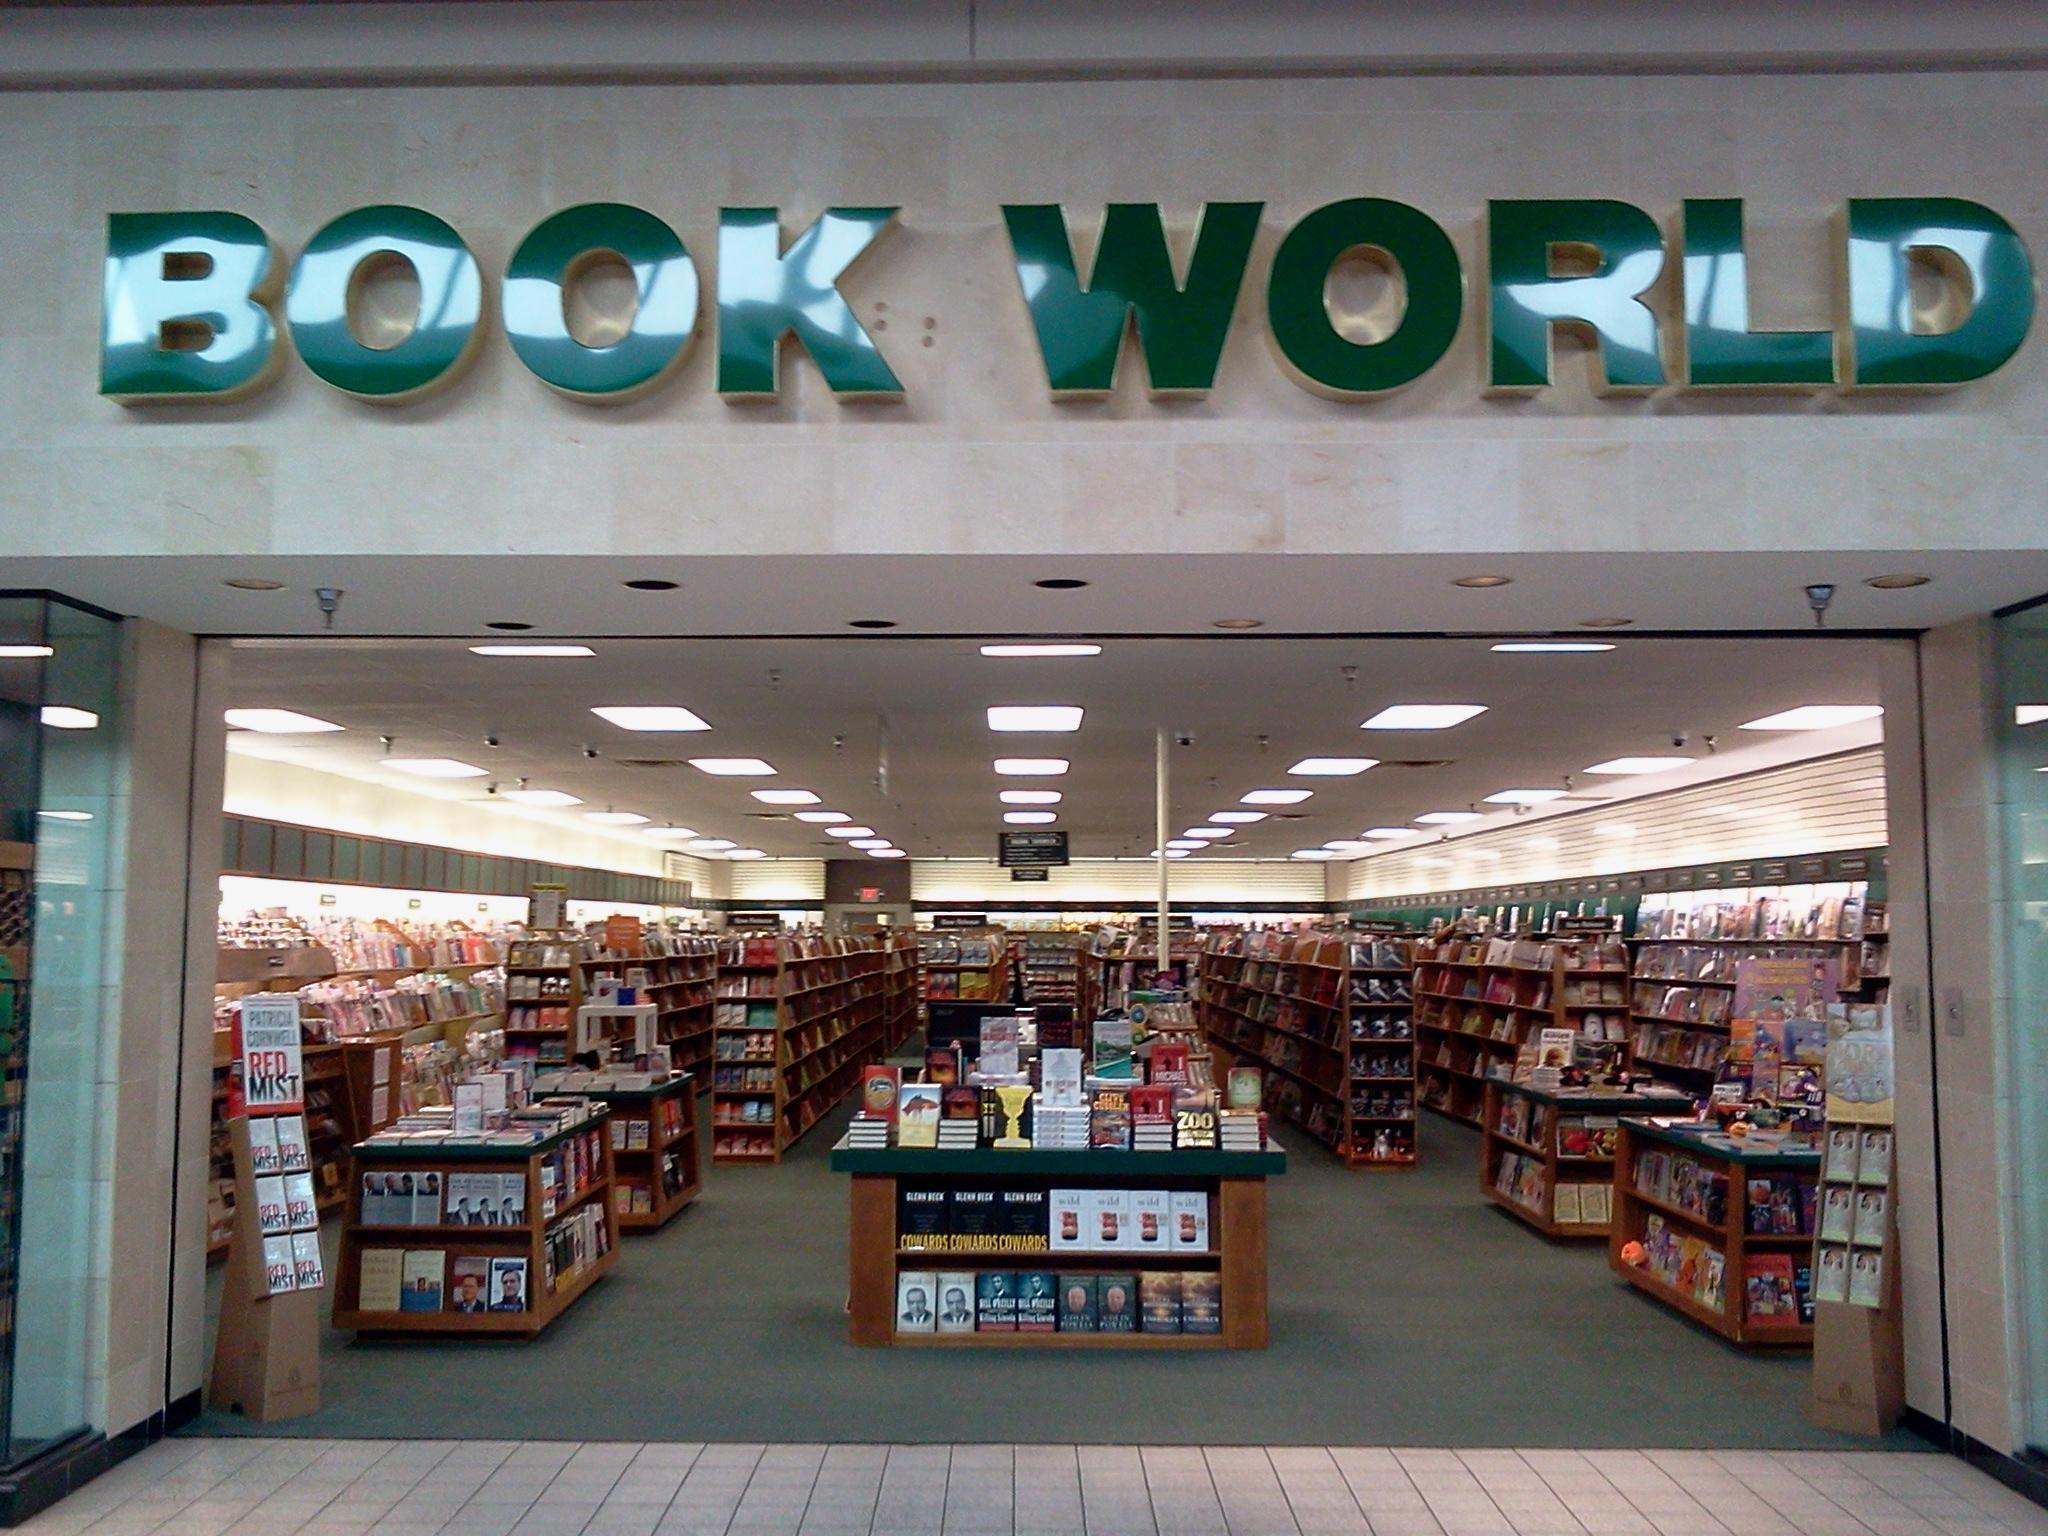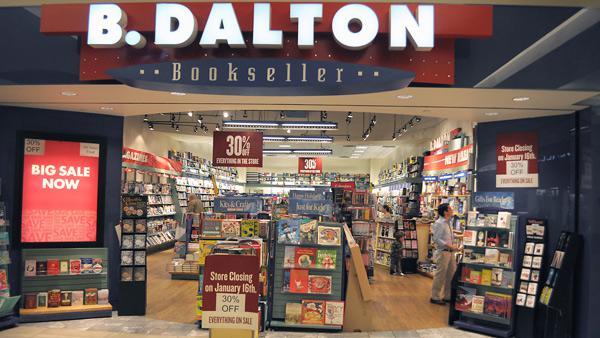The first image is the image on the left, the second image is the image on the right. For the images shown, is this caption "In one image, an awning with advertising extends over the front of a bookstore." true? Answer yes or no. No. 